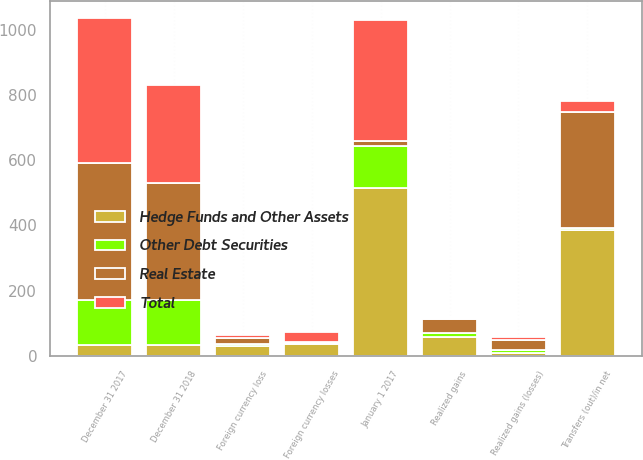Convert chart. <chart><loc_0><loc_0><loc_500><loc_500><stacked_bar_chart><ecel><fcel>January 1 2017<fcel>Realized gains<fcel>Transfers (out)/in net<fcel>Foreign currency losses<fcel>December 31 2017<fcel>Realized gains (losses)<fcel>Foreign currency loss<fcel>December 31 2018<nl><fcel>Other Debt Securities<fcel>129<fcel>11<fcel>5<fcel>3<fcel>138<fcel>9<fcel>4<fcel>137<nl><fcel>Real Estate<fcel>16<fcel>45<fcel>355<fcel>2<fcel>418<fcel>29<fcel>18<fcel>359<nl><fcel>Total<fcel>370<fcel>3<fcel>36<fcel>32<fcel>446<fcel>10<fcel>10<fcel>299<nl><fcel>Hedge Funds and Other Assets<fcel>515<fcel>59<fcel>386<fcel>37<fcel>34<fcel>10<fcel>32<fcel>34<nl></chart> 